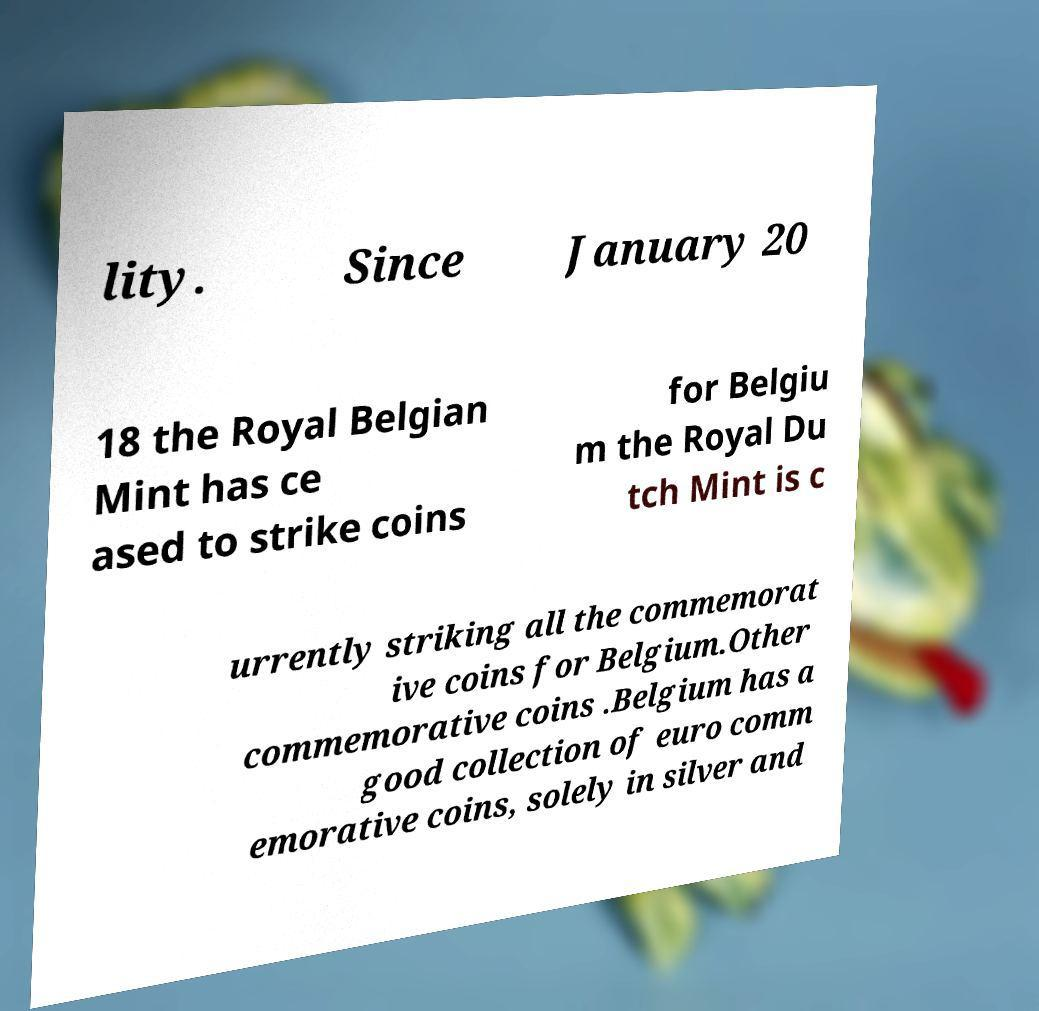Could you extract and type out the text from this image? lity. Since January 20 18 the Royal Belgian Mint has ce ased to strike coins for Belgiu m the Royal Du tch Mint is c urrently striking all the commemorat ive coins for Belgium.Other commemorative coins .Belgium has a good collection of euro comm emorative coins, solely in silver and 